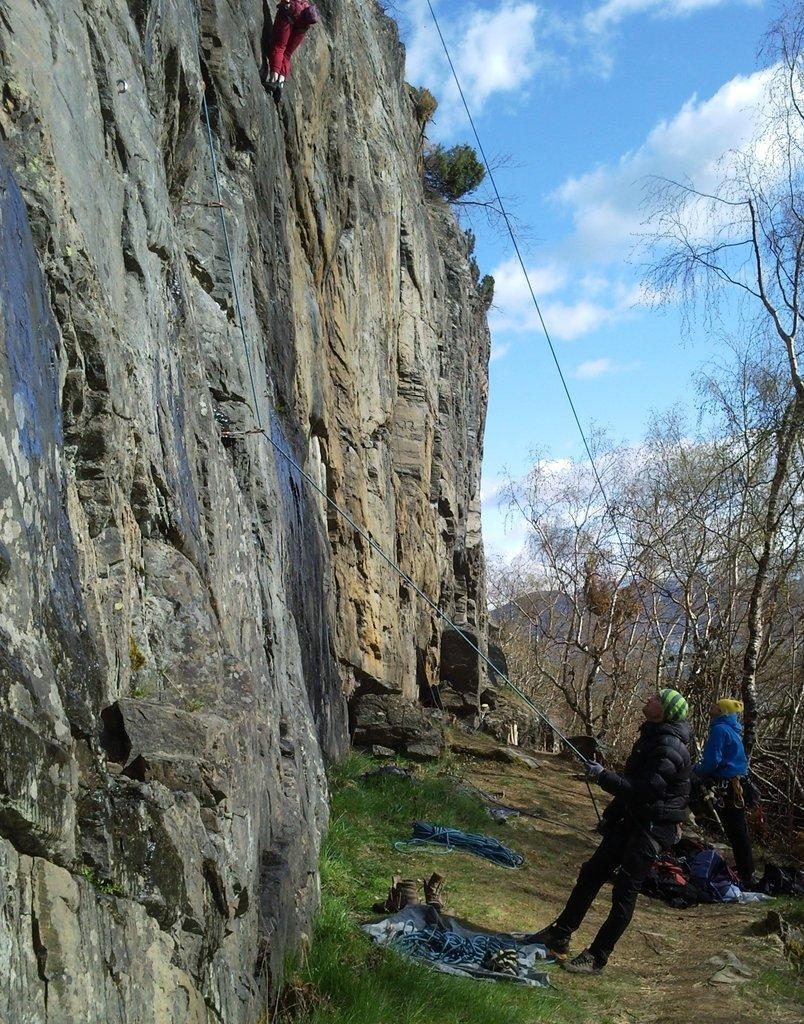In one or two sentences, can you explain what this image depicts? There is a person standing and holding a rope,behind this person we can see another person. We can see clothes,footwear and objects on the surface and grass. There is a person climbing on a rock. In the background we can see trees and sky with clouds. 